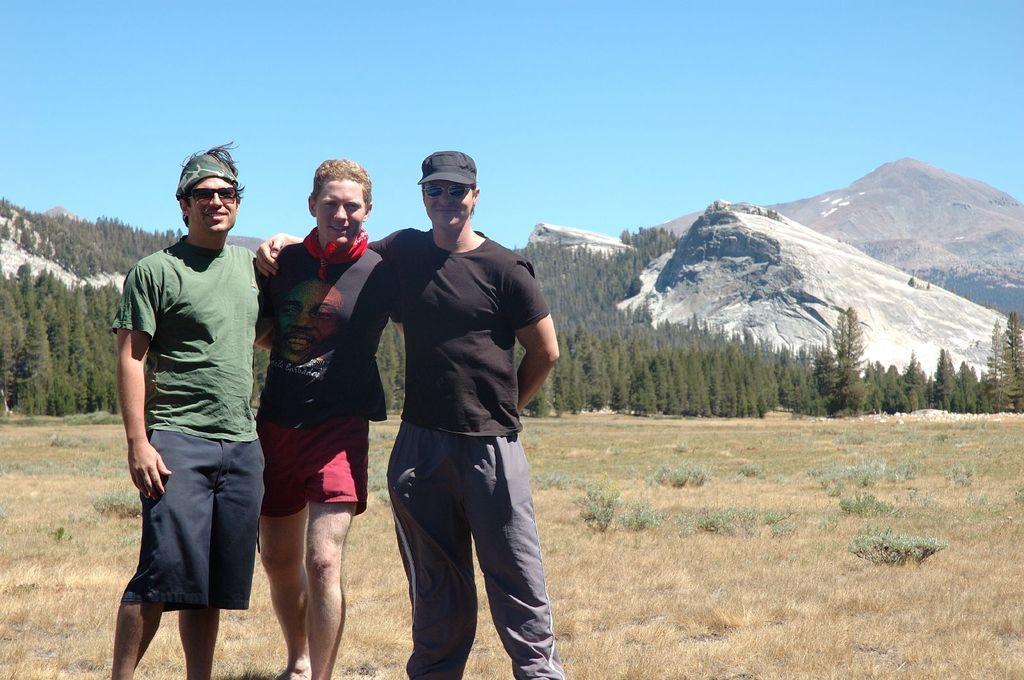Can you describe this image briefly? In this image I can see three persons wearing t shirts are standing on the ground. I can see some grass and few plants on the ground. In the background I can see few mountains, few trees and the sky. 